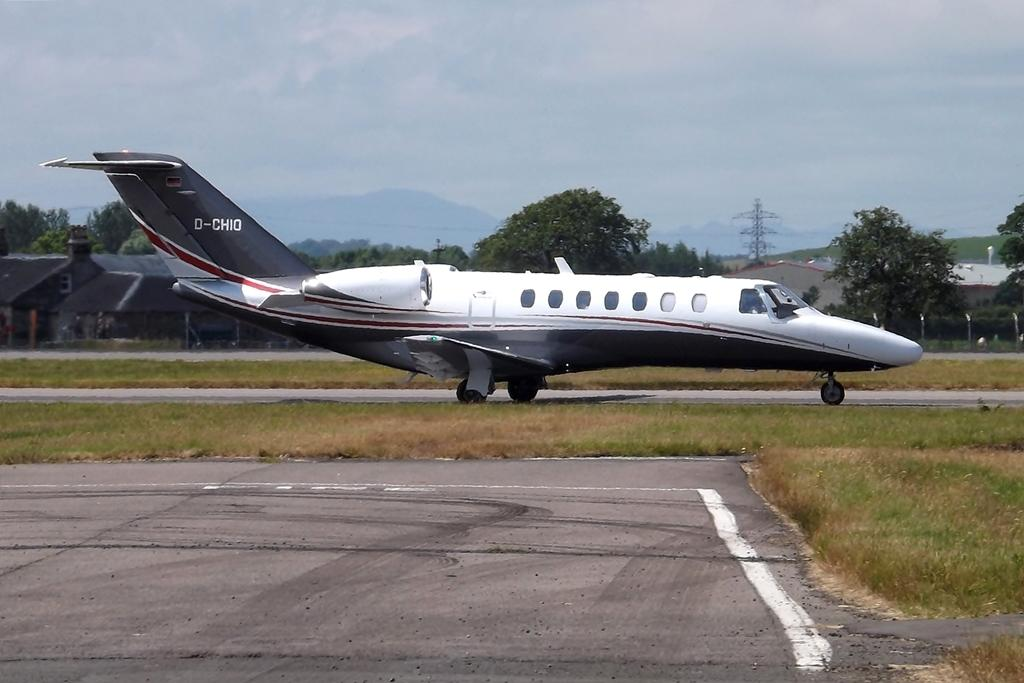<image>
Describe the image concisely. A plane on a runway has D-CHIO written on the tail. 